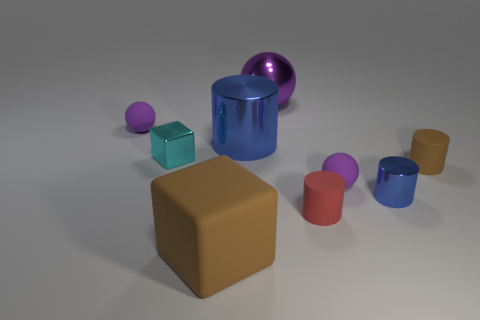There is a brown matte thing that is the same shape as the tiny cyan thing; what is its size?
Ensure brevity in your answer.  Large. How many objects are either blocks in front of the tiny metallic cube or tiny purple spheres?
Your answer should be very brief. 3. Is the color of the small metal cylinder the same as the big shiny cylinder?
Your answer should be very brief. Yes. Is there a brown cylinder of the same size as the cyan metal cube?
Make the answer very short. Yes. What number of objects are behind the brown matte cylinder and left of the big metallic cylinder?
Provide a succinct answer. 2. How many small matte balls are to the right of the big brown thing?
Provide a succinct answer. 1. Are there any red matte objects of the same shape as the small brown thing?
Provide a short and direct response. Yes. There is a tiny brown rubber thing; does it have the same shape as the large blue object that is behind the big brown thing?
Provide a short and direct response. Yes. How many cylinders are metallic objects or rubber objects?
Make the answer very short. 4. There is a shiny thing that is left of the big brown matte thing; what is its shape?
Your response must be concise. Cube. 